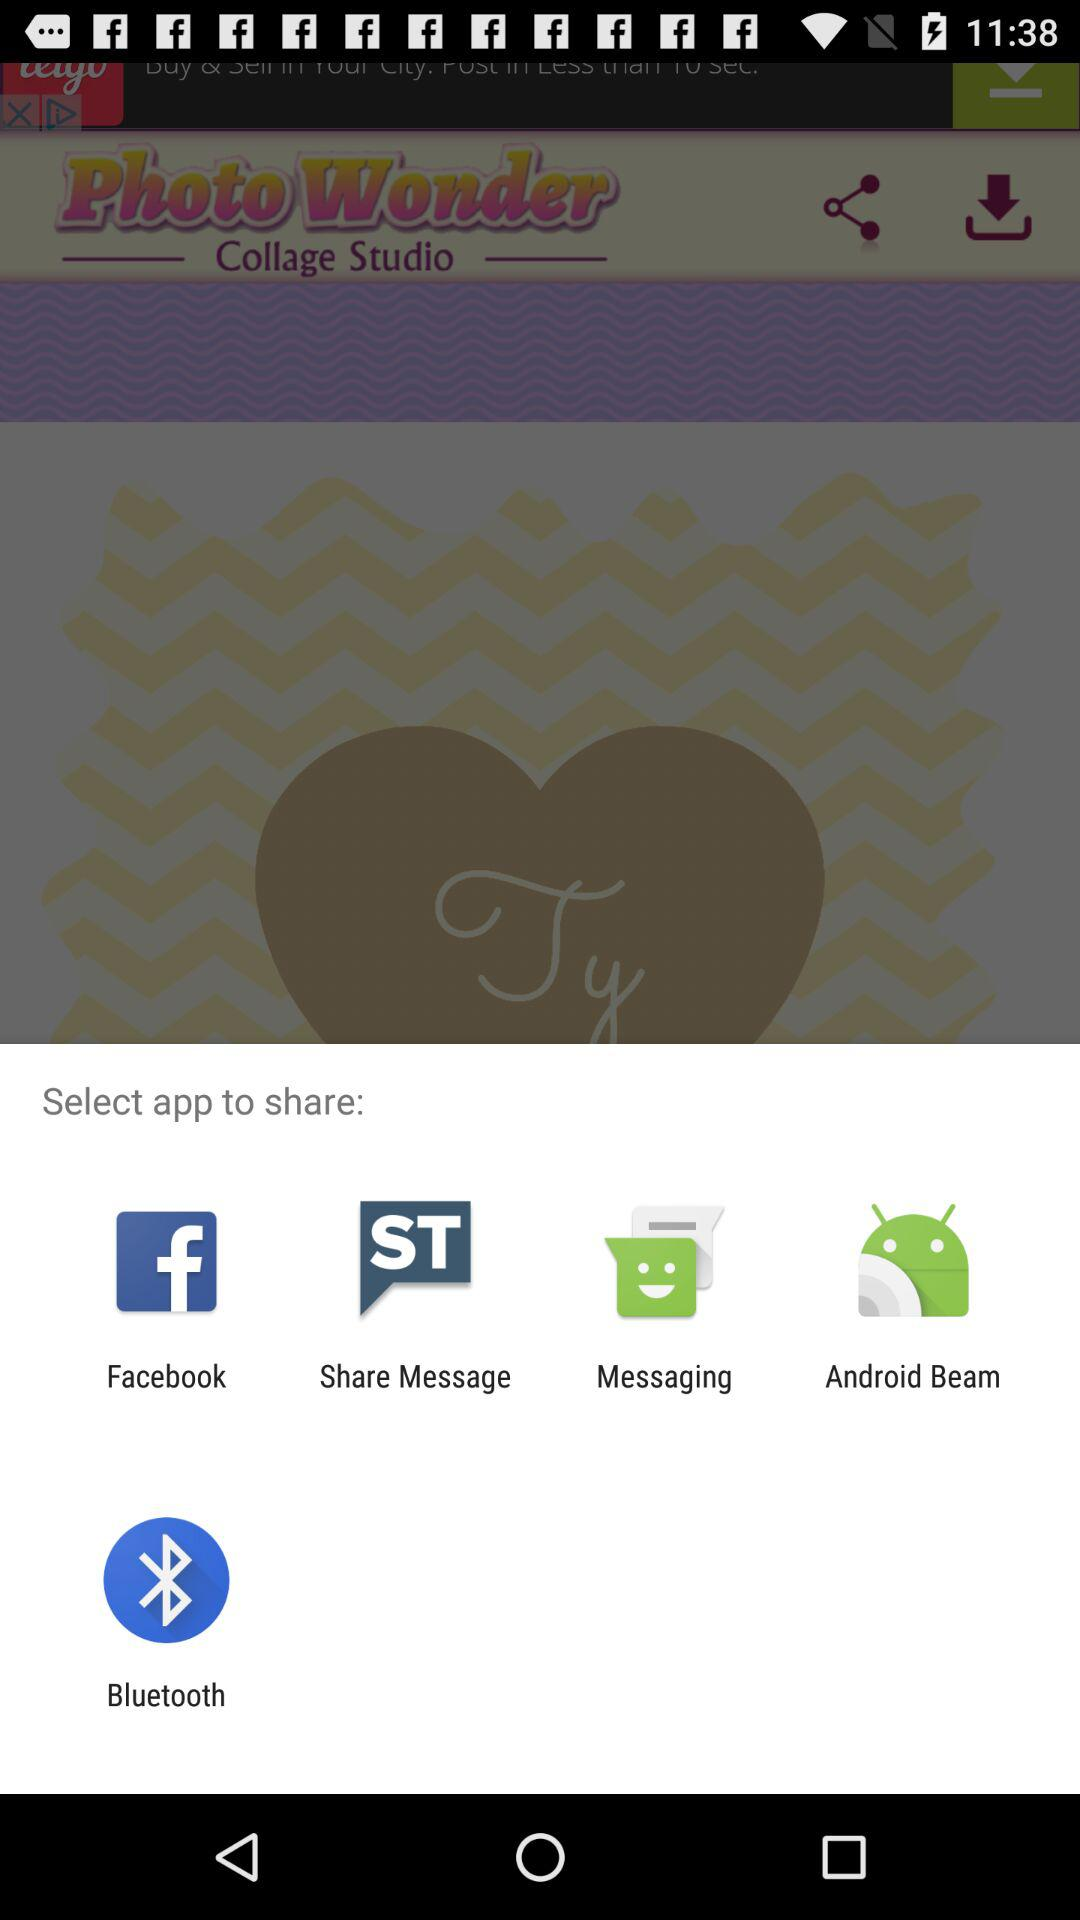What is the version number?
When the provided information is insufficient, respond with <no answer>. <no answer> 